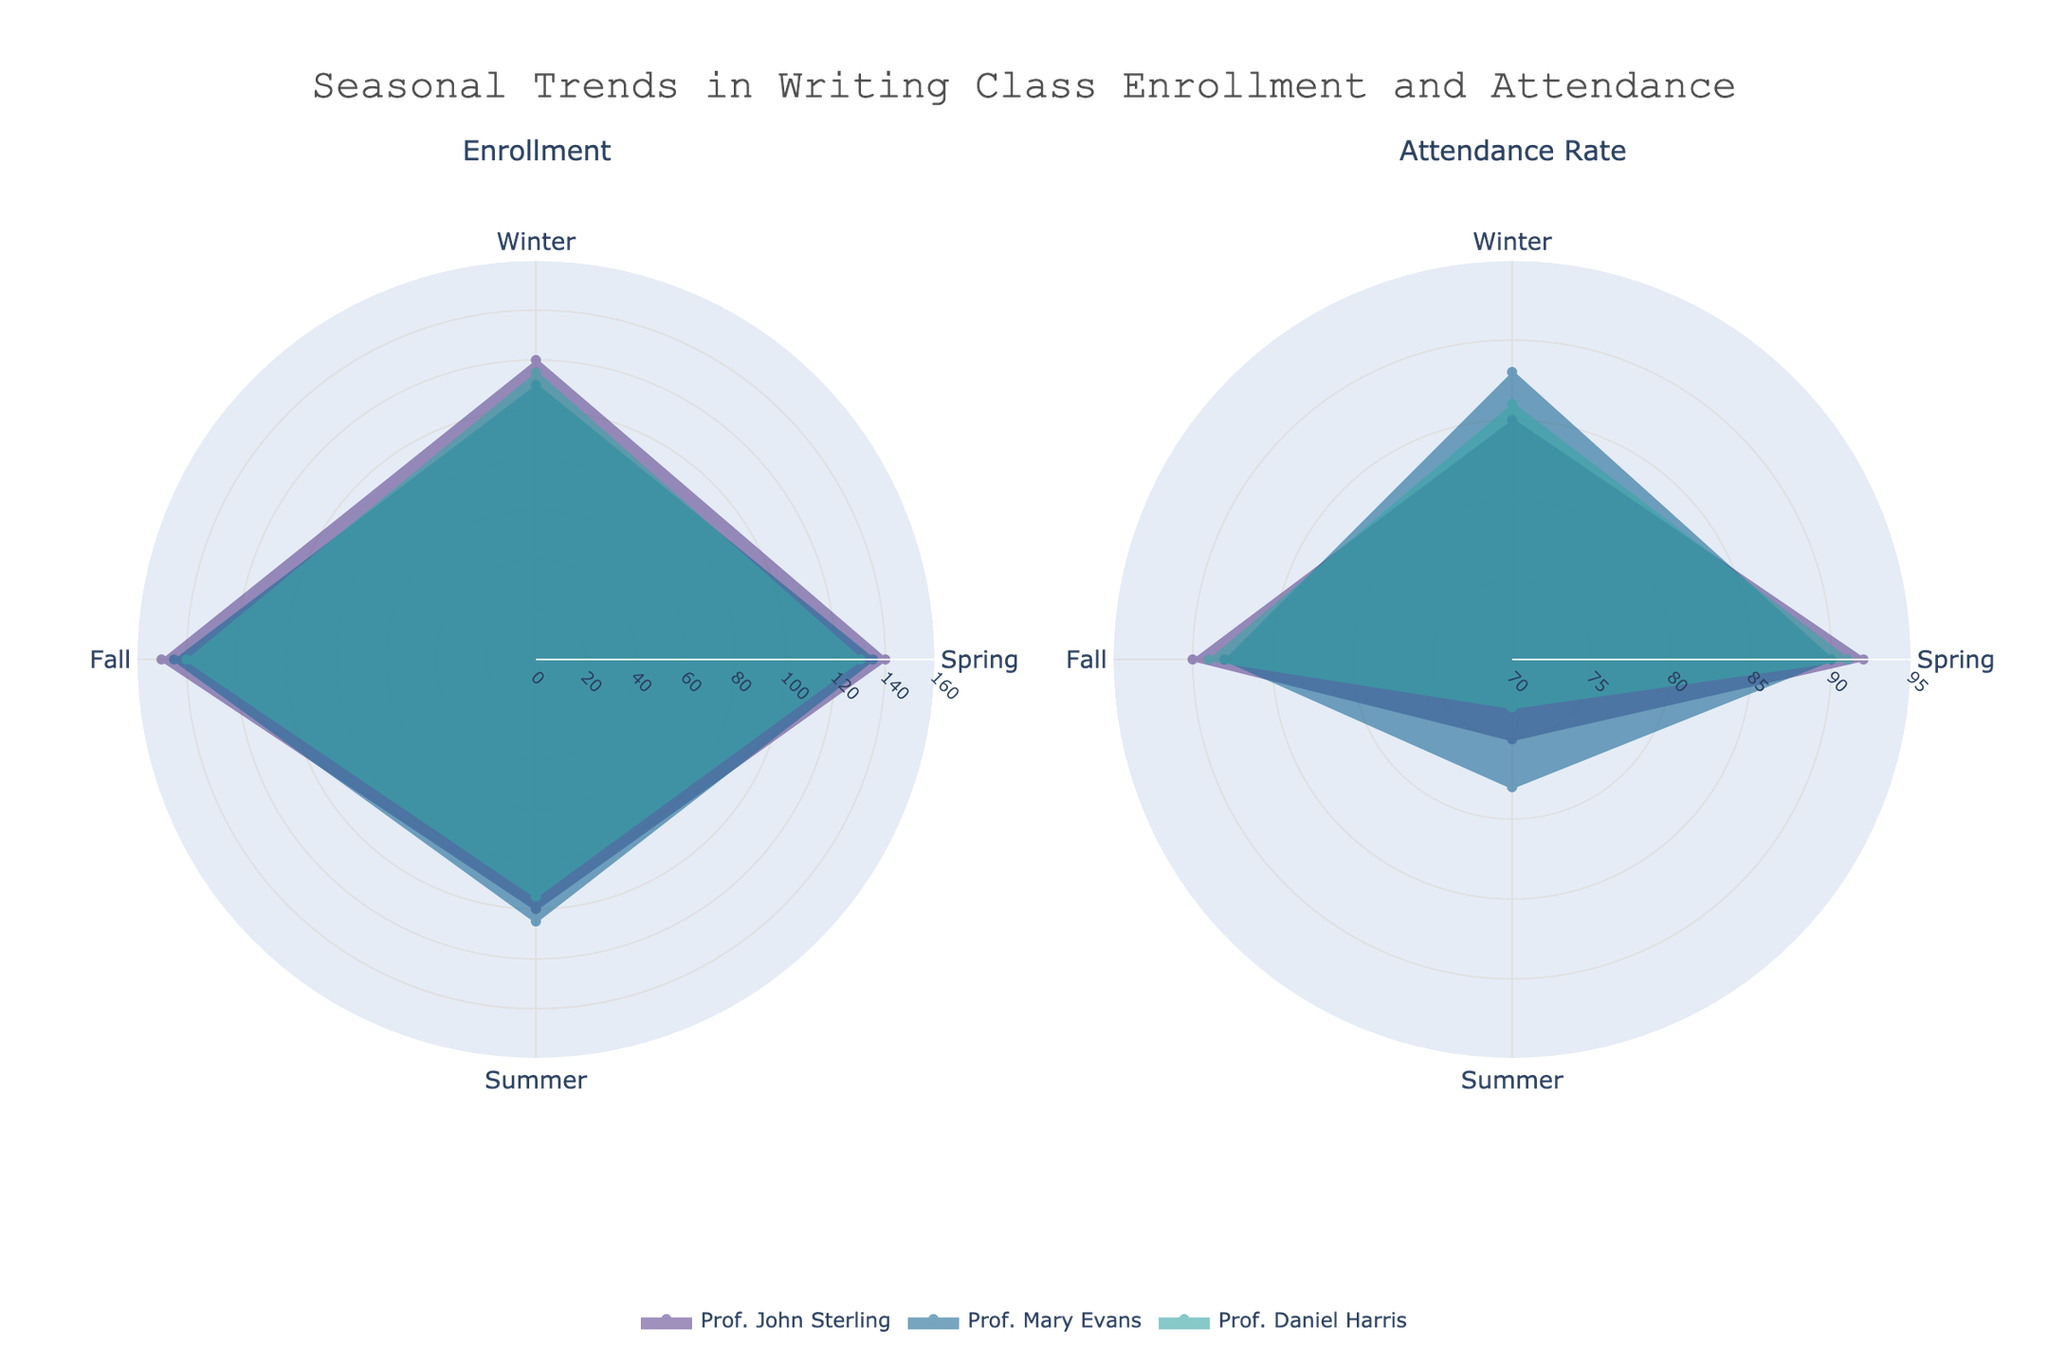What is the title of the rose chart? The title is positioned at the top center of the chart. It provides an overview of what the chart represents.
Answer: Seasonal Trends in Writing Class Enrollment and Attendance Which season has the highest adjusted enrollment overall? By looking at the radial extent of the regions in each season on the left subplot (Enrollment), the season with the largest radius, indicating the highest enrollment, can be identified.
Answer: Fall Which professor had the highest attendance rate in Spring? By comparing the radial extent of the regions representing the Attendance Rate for each professor during the Spring on the right subplot, the professor with the largest radius can be identified.
Answer: Prof. John Sterling Is the attendance rate higher in Winter or Summer for Prof. Mary Evans? To determine this, compare the radial extents in the Attendance Rate plot for both Winter and Summer slices corresponding to Prof. Mary Evans's color.
Answer: Winter What is the average adjusted enrollment in Spring for all professors? Sum the adjusted enrollments in Spring for all professors and divide by the number of professors: (140 + 135 + 130) / 3.
Answer: 135 Between Prof. John Sterling and Prof. Daniel Harris, who has a higher attendance rate in Fall? Compare the radial extents of the Attendance Rate plot in Fall for these two professors. The professor with the larger radius has the higher attendance rate.
Answer: Prof. John Sterling Which professor exhibits the greatest variation in adjusted enrollments across seasons? To determine the greatest variation, compare the difference between the maximum and minimum values of adjusted enrollments for each professor across seasons.
Answer: Prof. John Sterling Are the attendance rates in Fall for all professors above 85%? By examining the radial extents in the Attendance Rate plot for all professors during Fall, check if all exceed the 85% radial mark.
Answer: Yes How does Prof. Daniel Harris's adjusted enrollment in Summer compare to his adjusted enrollment in Winter? Compare the radial extent of the Summer slice to the Winter slice in the Enrollment plot for Prof. Daniel Harris.
Answer: Lower in Summer What is the combined adjusted enrollment in Winter for all professors? Sum the adjusted enrollments in Winter for all professors: 120 + 110 + 115.
Answer: 345 